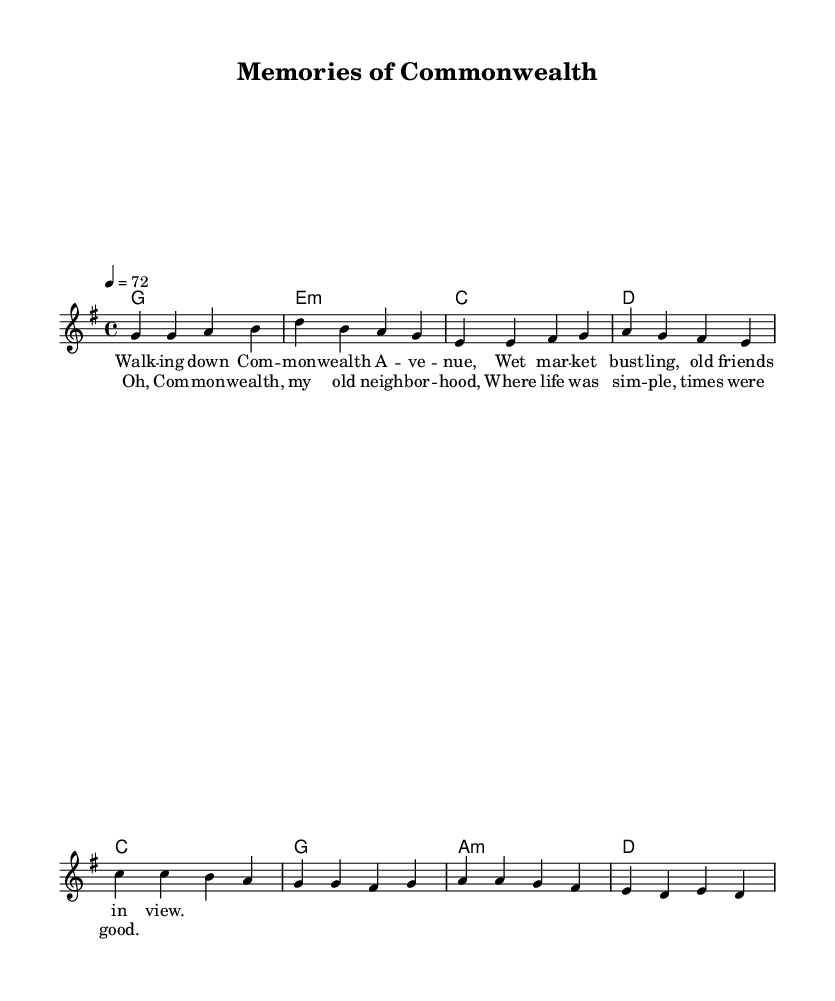What is the key signature of this music? The key signature has one sharp, indicating that it is in G major.
Answer: G major What is the time signature of this music? The time signature is displayed as 4/4, which means there are four beats in each measure and the quarter note gets one beat.
Answer: 4/4 What is the tempo marking? The tempo is marked at 72 beats per minute, indicated by the number under the tempo marking.
Answer: 72 What type of song structure is used in this piece? The piece contains verses followed by a chorus, which is typical in many songs, indicating a structure of alternating sections.
Answer: Verse-Chorus How many measures are in the chorus? The chorus consists of four measures, as can be counted from the notation laid out in the sheet music.
Answer: Four What is the tempo marking in terms of beats per minute? The tempo is explicitly marked as 72, meaning there are 72 beats per minute indicated in the sheet music.
Answer: 72 Is the mood of this piece typical for reggae music? Yes, the nostalgic lyrics and melodic content align well with the relaxed and reflective nature common in reggae music.
Answer: Yes 